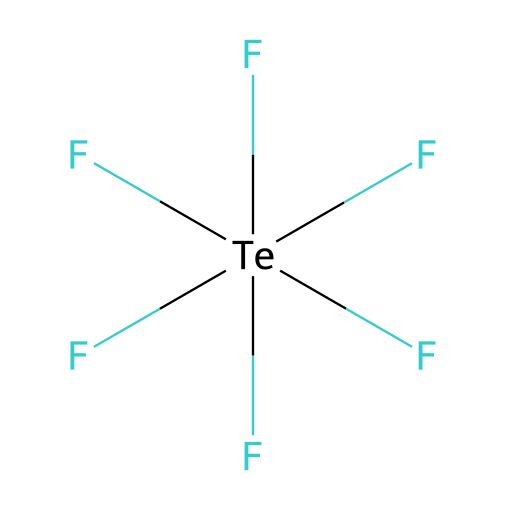What is the central atom in this compound? The chemical formula shows that tellurium (Te) is the central atom around which six fluorine (F) atoms are arranged.
Answer: tellurium How many fluorine atoms are attached to the central atom? The SMILES representation indicates that there are six fluorine atoms connected to the tellurium atom, as indicated by the six F symbols.
Answer: six What type of bonding is exhibited by this compound? The compound has covalent bonds between tellurium and the fluorine atoms, as suggested by the shared electron pairs in the structure.
Answer: covalent Is tellurium hexafluoride a hypervalent compound? The structure contains a central atom (tellurium) with more than four bonds (six in this case), which classifies it as a hypervalent compound.
Answer: yes What geometry does tellurium hexafluoride exhibit? Given the six surrounding fluorine atoms, the molecular geometry is octahedral, which is typical for compounds with six bonded pairs.
Answer: octahedral How many lone pairs does the tellurium atom have in this compound? In the structure, tellurium is bonded to six fluorine atoms and has no lone pairs remaining on it, as all valence electrons are involved in bonding.
Answer: zero 